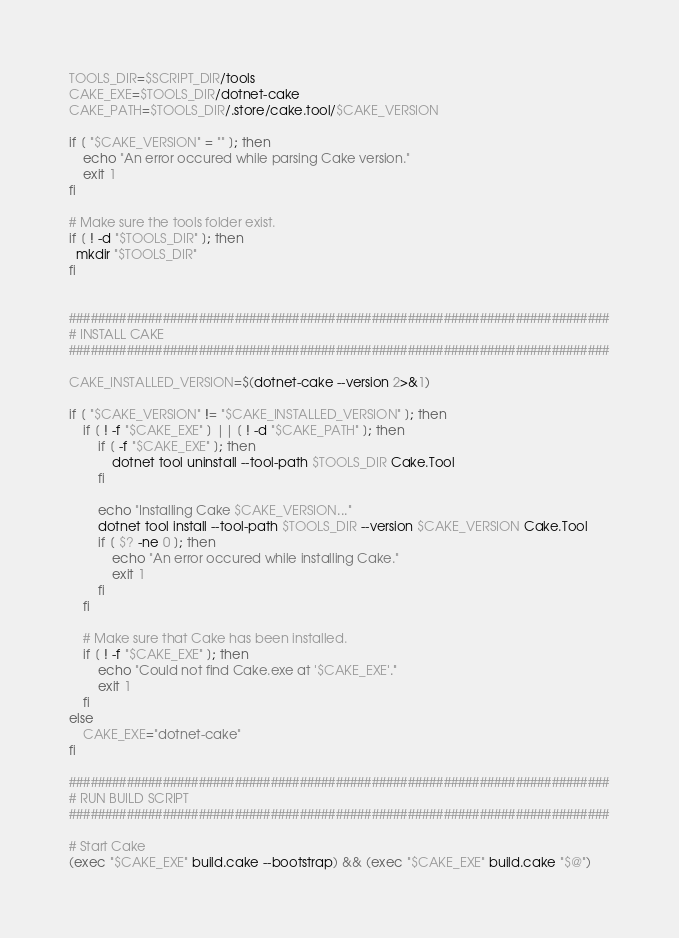<code> <loc_0><loc_0><loc_500><loc_500><_Bash_>TOOLS_DIR=$SCRIPT_DIR/tools
CAKE_EXE=$TOOLS_DIR/dotnet-cake
CAKE_PATH=$TOOLS_DIR/.store/cake.tool/$CAKE_VERSION

if [ "$CAKE_VERSION" = "" ]; then
    echo "An error occured while parsing Cake version."
    exit 1
fi

# Make sure the tools folder exist.
if [ ! -d "$TOOLS_DIR" ]; then
  mkdir "$TOOLS_DIR"
fi


###########################################################################
# INSTALL CAKE
###########################################################################

CAKE_INSTALLED_VERSION=$(dotnet-cake --version 2>&1)

if [ "$CAKE_VERSION" != "$CAKE_INSTALLED_VERSION" ]; then
    if [ ! -f "$CAKE_EXE" ] || [ ! -d "$CAKE_PATH" ]; then
        if [ -f "$CAKE_EXE" ]; then
            dotnet tool uninstall --tool-path $TOOLS_DIR Cake.Tool
        fi

        echo "Installing Cake $CAKE_VERSION..."
        dotnet tool install --tool-path $TOOLS_DIR --version $CAKE_VERSION Cake.Tool
        if [ $? -ne 0 ]; then
            echo "An error occured while installing Cake."
            exit 1
        fi
    fi

    # Make sure that Cake has been installed.
    if [ ! -f "$CAKE_EXE" ]; then
        echo "Could not find Cake.exe at '$CAKE_EXE'."
        exit 1
    fi
else
    CAKE_EXE="dotnet-cake"
fi

###########################################################################
# RUN BUILD SCRIPT
###########################################################################

# Start Cake
(exec "$CAKE_EXE" build.cake --bootstrap) && (exec "$CAKE_EXE" build.cake "$@")</code> 